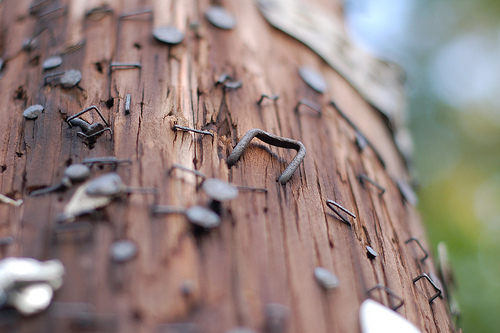<image>
Is there a nail to the left of the telephone pole? No. The nail is not to the left of the telephone pole. From this viewpoint, they have a different horizontal relationship. 